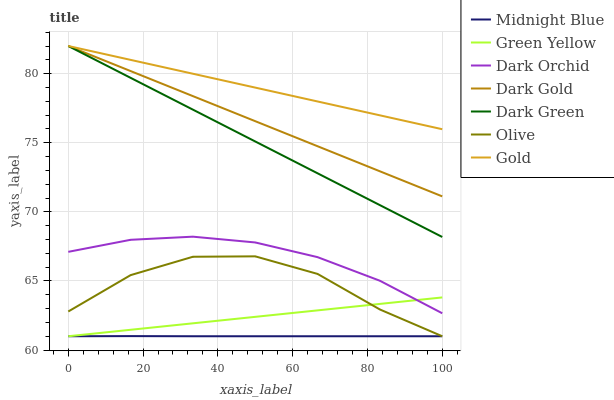Does Midnight Blue have the minimum area under the curve?
Answer yes or no. Yes. Does Gold have the maximum area under the curve?
Answer yes or no. Yes. Does Dark Gold have the minimum area under the curve?
Answer yes or no. No. Does Dark Gold have the maximum area under the curve?
Answer yes or no. No. Is Green Yellow the smoothest?
Answer yes or no. Yes. Is Olive the roughest?
Answer yes or no. Yes. Is Gold the smoothest?
Answer yes or no. No. Is Gold the roughest?
Answer yes or no. No. Does Midnight Blue have the lowest value?
Answer yes or no. Yes. Does Dark Gold have the lowest value?
Answer yes or no. No. Does Dark Green have the highest value?
Answer yes or no. Yes. Does Dark Orchid have the highest value?
Answer yes or no. No. Is Dark Orchid less than Gold?
Answer yes or no. Yes. Is Dark Green greater than Midnight Blue?
Answer yes or no. Yes. Does Gold intersect Dark Gold?
Answer yes or no. Yes. Is Gold less than Dark Gold?
Answer yes or no. No. Is Gold greater than Dark Gold?
Answer yes or no. No. Does Dark Orchid intersect Gold?
Answer yes or no. No. 